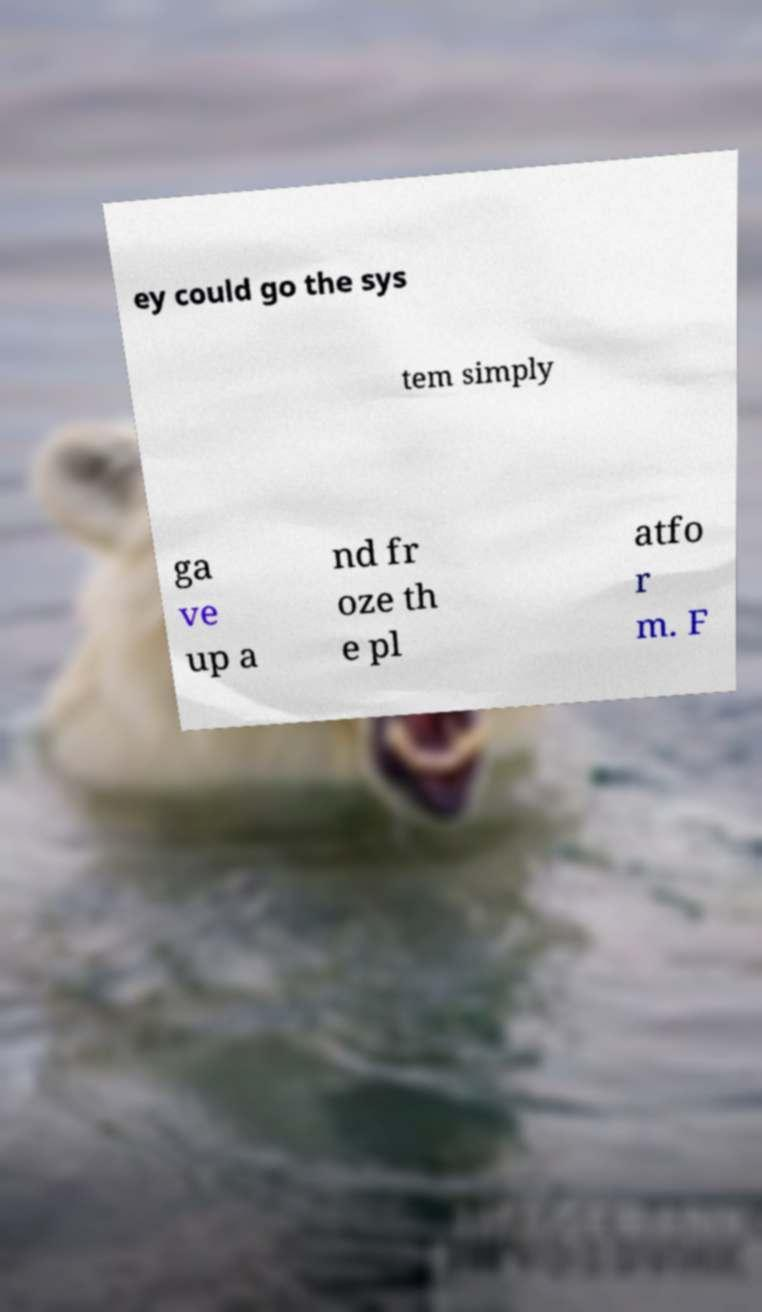Please identify and transcribe the text found in this image. ey could go the sys tem simply ga ve up a nd fr oze th e pl atfo r m. F 